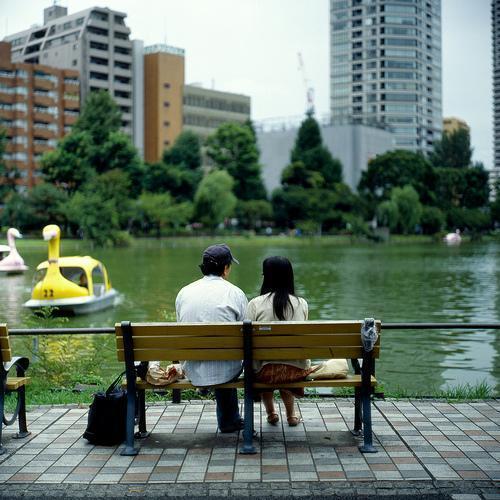How many people on the benh?
Give a very brief answer. 2. 